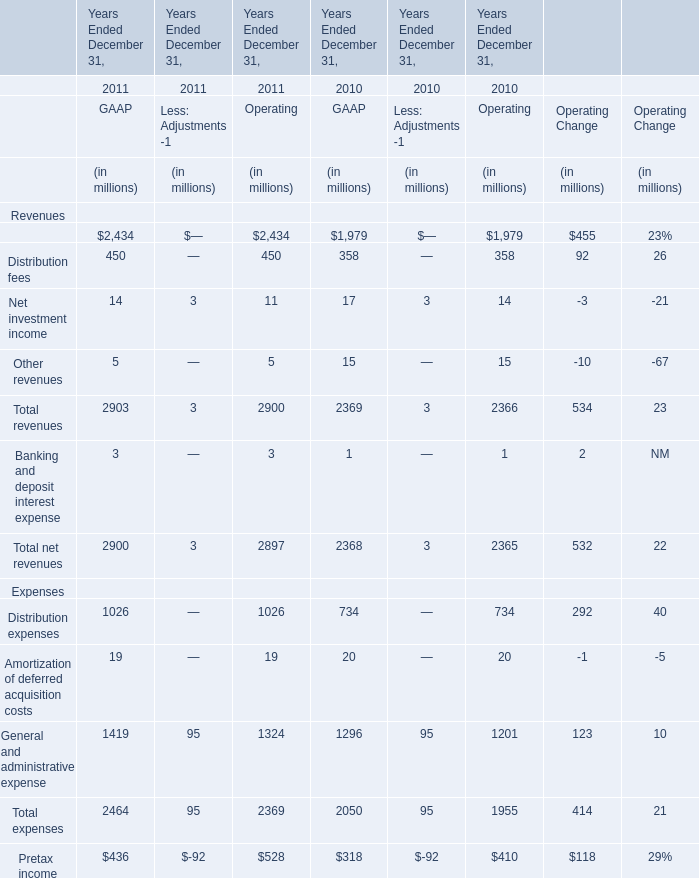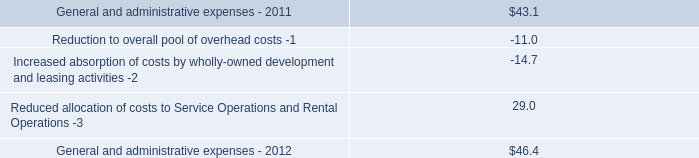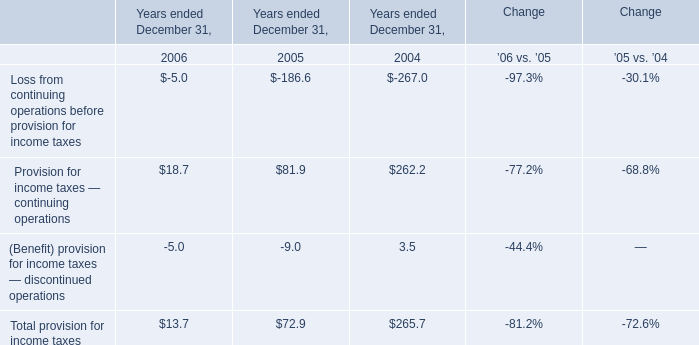What's the growth rate of GAAP's Management and financial advice fees in 2011? 
Computations: ((2434 - 1979) / 1979)
Answer: 0.22991. what was the percent increase of the interest expense allocable to continuing operations in 2012 to 2011 
Computations: ((245.2 - 220.5) / 220.5)
Answer: 0.11202. 